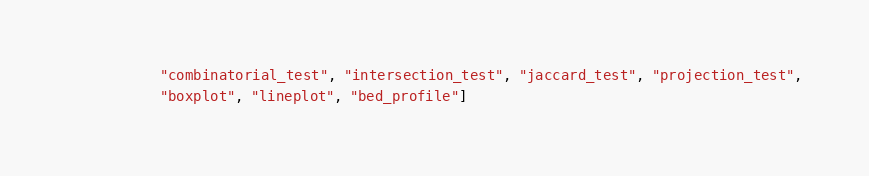Convert code to text. <code><loc_0><loc_0><loc_500><loc_500><_Python_>           "combinatorial_test", "intersection_test", "jaccard_test", "projection_test",
           "boxplot", "lineplot", "bed_profile"]
</code> 